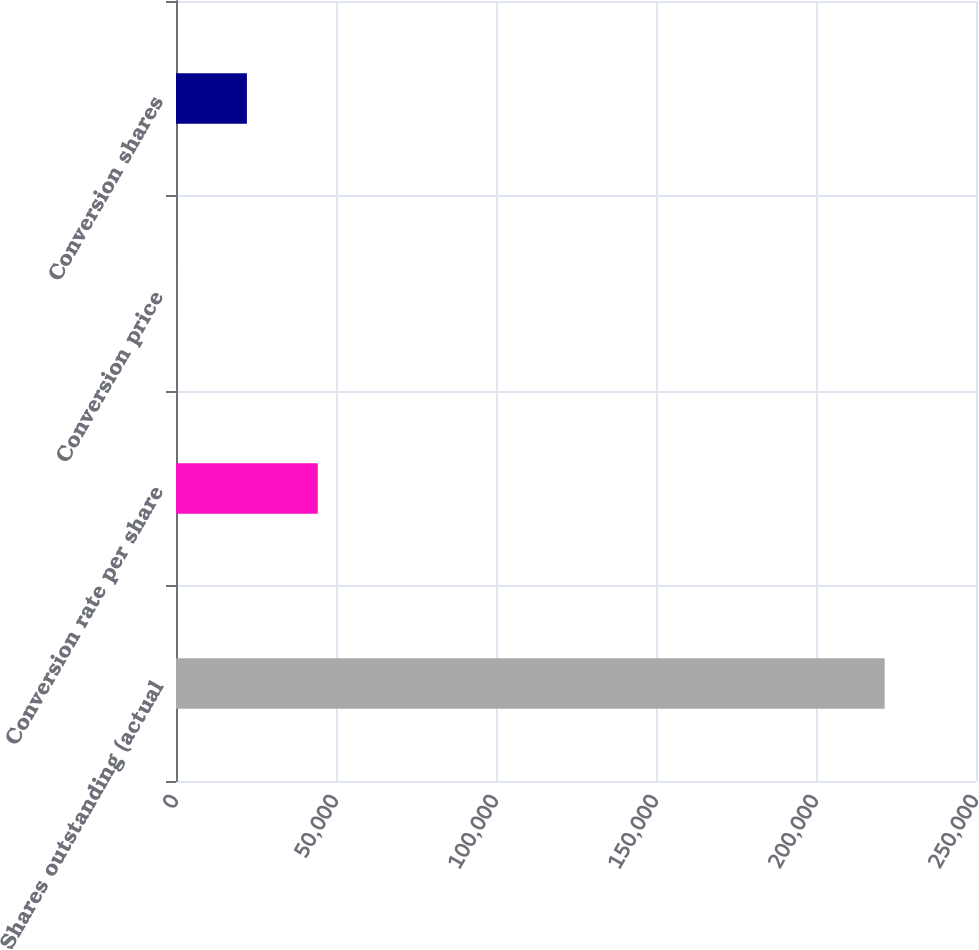<chart> <loc_0><loc_0><loc_500><loc_500><bar_chart><fcel>Shares outstanding (actual<fcel>Conversion rate per share<fcel>Conversion price<fcel>Conversion shares<nl><fcel>221474<fcel>44305.3<fcel>13.12<fcel>22159.2<nl></chart> 